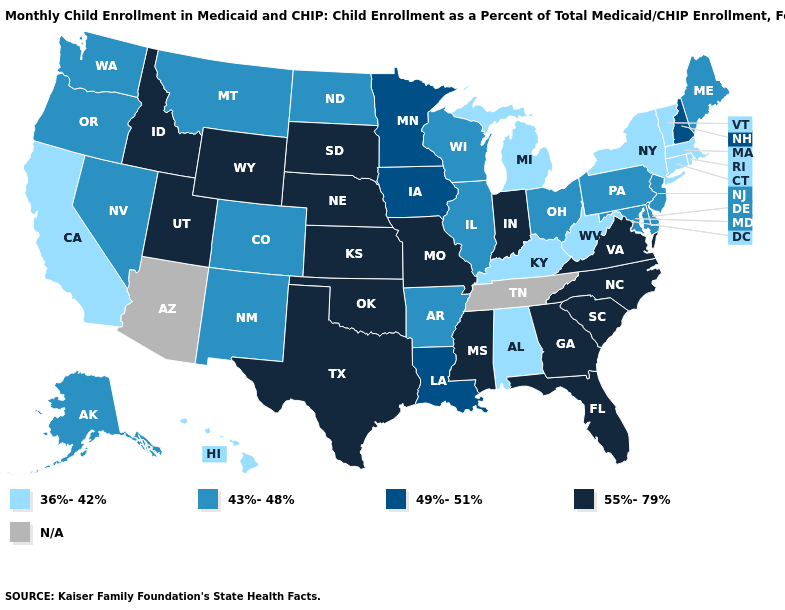Does the map have missing data?
Concise answer only. Yes. What is the highest value in the MidWest ?
Answer briefly. 55%-79%. What is the highest value in the USA?
Write a very short answer. 55%-79%. What is the value of Florida?
Answer briefly. 55%-79%. What is the lowest value in states that border Kentucky?
Keep it brief. 36%-42%. Name the states that have a value in the range 55%-79%?
Answer briefly. Florida, Georgia, Idaho, Indiana, Kansas, Mississippi, Missouri, Nebraska, North Carolina, Oklahoma, South Carolina, South Dakota, Texas, Utah, Virginia, Wyoming. Does Maryland have the lowest value in the South?
Write a very short answer. No. What is the lowest value in the USA?
Keep it brief. 36%-42%. Name the states that have a value in the range 49%-51%?
Be succinct. Iowa, Louisiana, Minnesota, New Hampshire. Among the states that border Louisiana , does Arkansas have the lowest value?
Write a very short answer. Yes. Name the states that have a value in the range 43%-48%?
Write a very short answer. Alaska, Arkansas, Colorado, Delaware, Illinois, Maine, Maryland, Montana, Nevada, New Jersey, New Mexico, North Dakota, Ohio, Oregon, Pennsylvania, Washington, Wisconsin. Name the states that have a value in the range 36%-42%?
Keep it brief. Alabama, California, Connecticut, Hawaii, Kentucky, Massachusetts, Michigan, New York, Rhode Island, Vermont, West Virginia. What is the value of Florida?
Answer briefly. 55%-79%. How many symbols are there in the legend?
Quick response, please. 5. What is the value of Kentucky?
Be succinct. 36%-42%. 